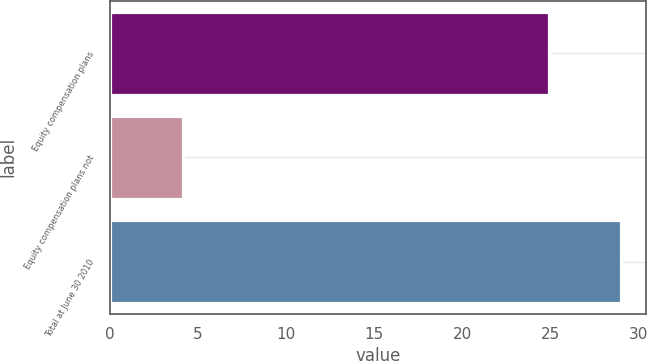<chart> <loc_0><loc_0><loc_500><loc_500><bar_chart><fcel>Equity compensation plans<fcel>Equity compensation plans not<fcel>Total at June 30 2010<nl><fcel>24.93<fcel>4.16<fcel>29<nl></chart> 